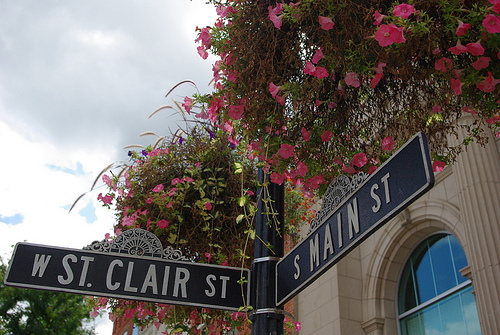<image>How many people live in Main Street? It is unknown how many people live in Main Street. How many people live in Main Street? I don't know how many people live in Main Street. It could be 100, 450, or unknown. 